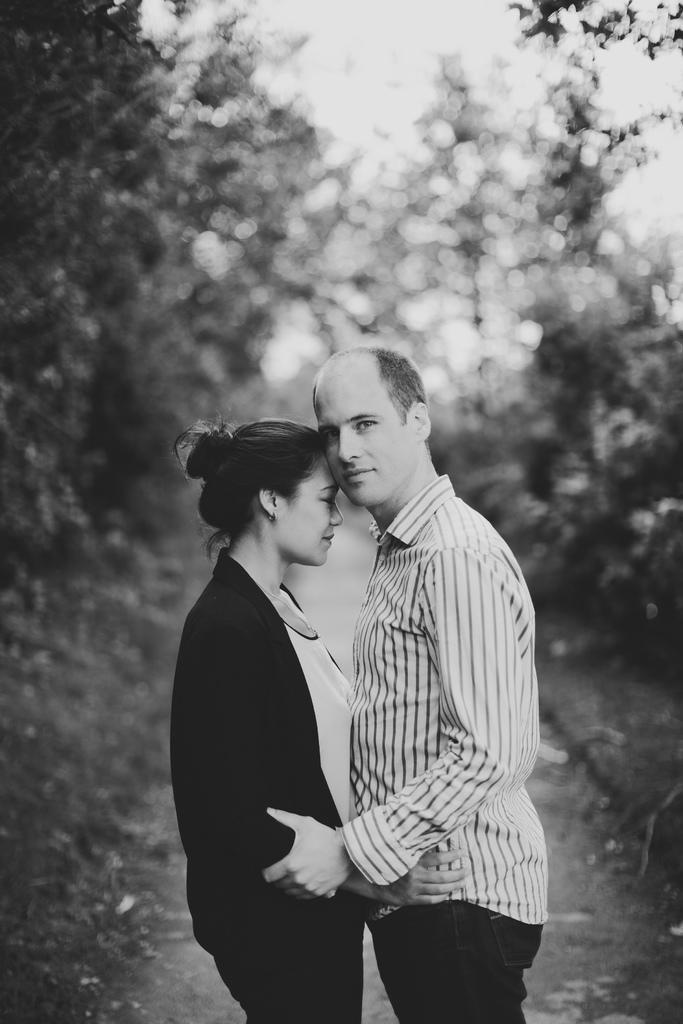In one or two sentences, can you explain what this image depicts? In this black and white picture there is a woman standing on the land. Before her there is a person holding her hand. Background there are trees. Top of the image there is sky. 